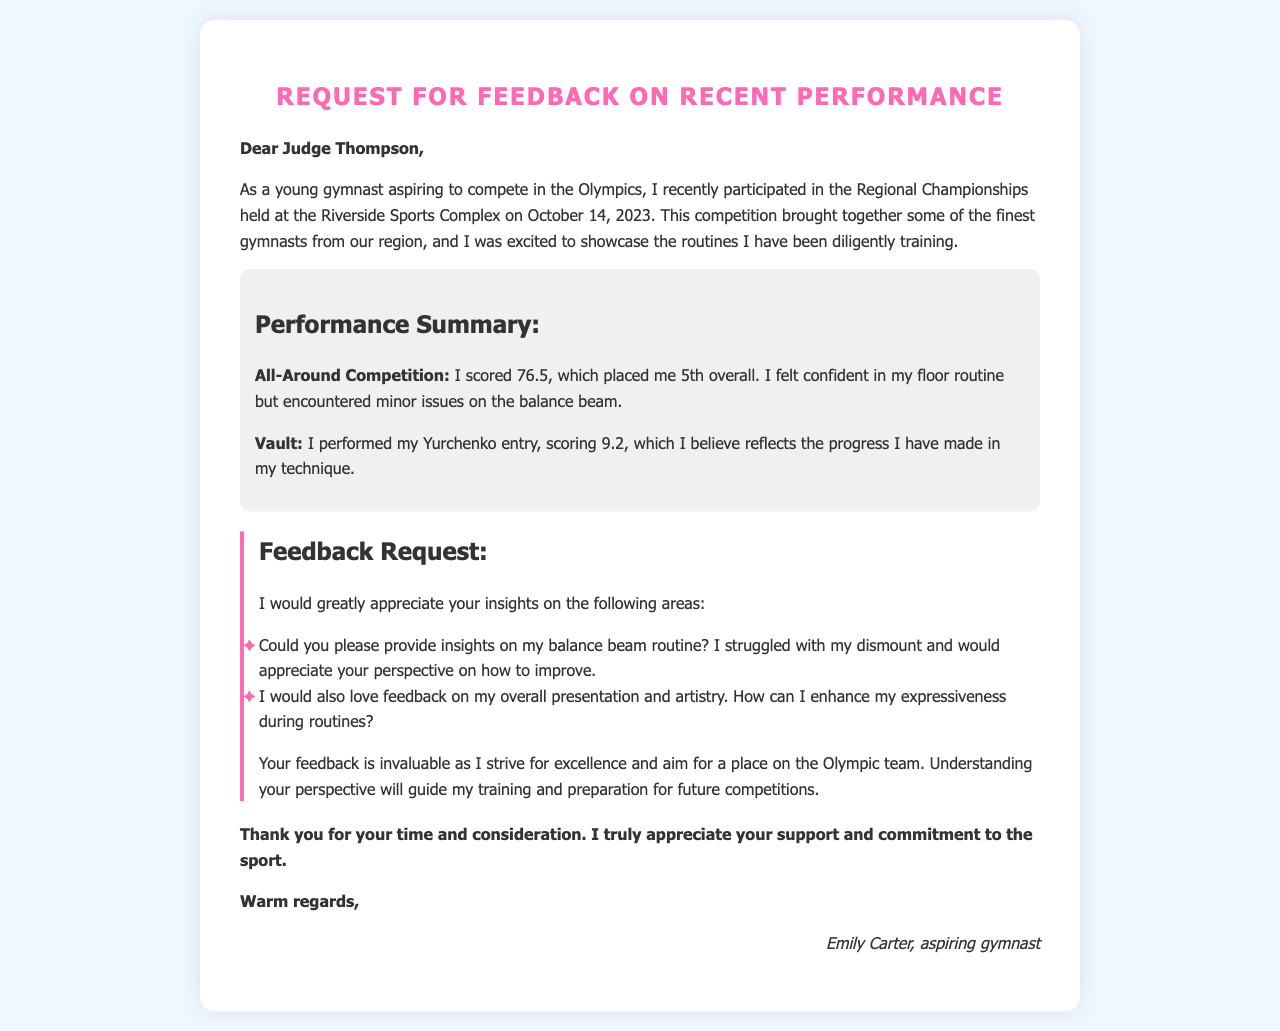What is the name of the judge addressed in the letter? The judge is addressed as Judge Thompson in the letter.
Answer: Judge Thompson What date was the Regional Championships held? The Regional Championships took place on October 14, 2023.
Answer: October 14, 2023 What was Emily's score in the all-around competition? Emily scored 76.5 in the all-around competition.
Answer: 76.5 What position did Emily achieve overall in the competition? Emily placed 5th overall in the competition.
Answer: 5th What specific routine did Emily struggle with? Emily encountered minor issues specifically on the balance beam routine.
Answer: balance beam What type of vault did Emily perform? Emily performed a Yurchenko entry for her vault routine.
Answer: Yurchenko What feedback does Emily seek regarding her performance? Emily seeks feedback on her balance beam routine and overall presentation.
Answer: balance beam routine and overall presentation Why does Emily consider feedback to be valuable? Emily considers feedback invaluable as it guides her training and preparation for future competitions.
Answer: guides her training and preparation What is Emily's ultimate aspiration as stated in the letter? Emily's ultimate aspiration is to compete in the Olympics.
Answer: compete in the Olympics 